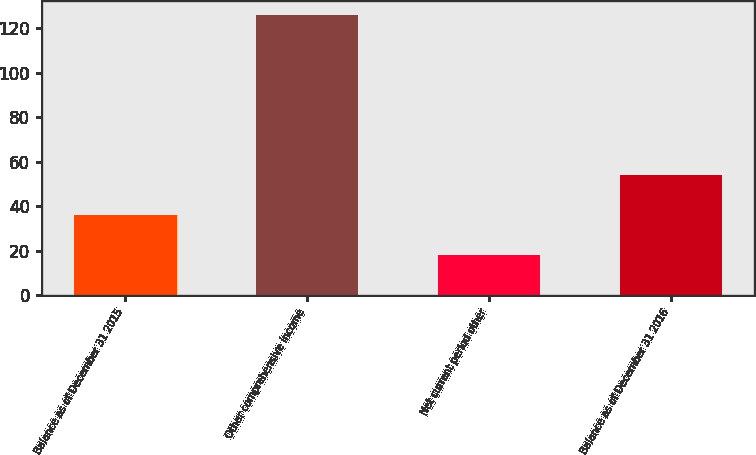<chart> <loc_0><loc_0><loc_500><loc_500><bar_chart><fcel>Balance as of December 31 2015<fcel>Other comprehensive income<fcel>Net current period other<fcel>Balance as of December 31 2016<nl><fcel>36<fcel>126<fcel>18<fcel>54<nl></chart> 